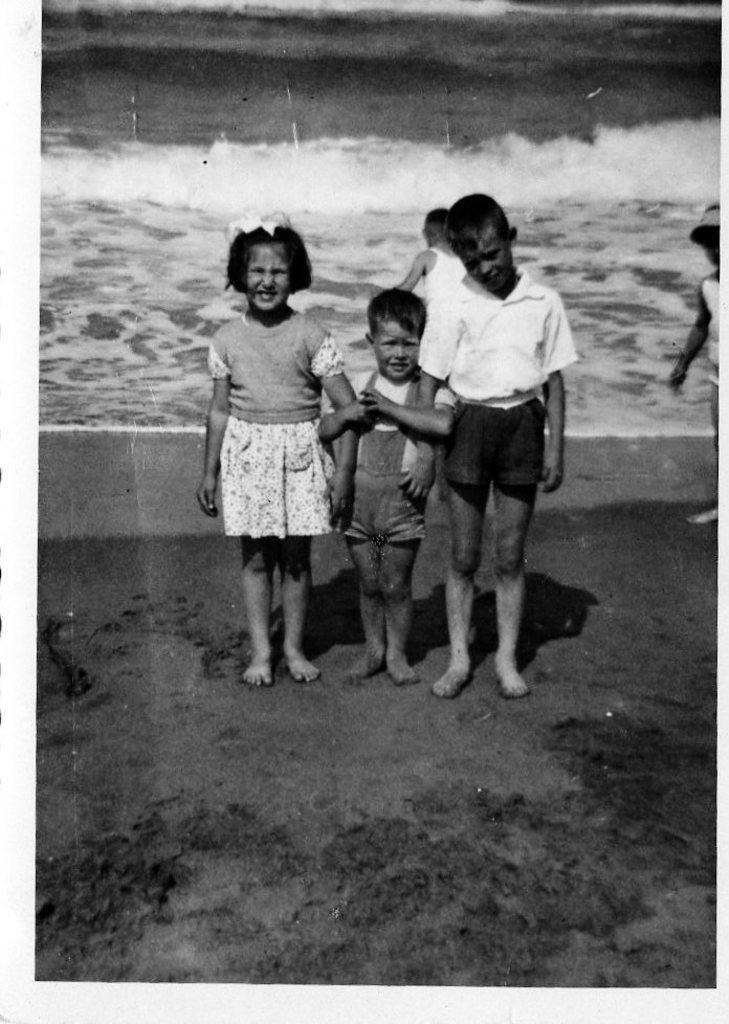How many children are in the image? There are three children in the image. What is the surface the children are standing on? The children are standing on the sand. What can be seen in the background of the image? There is an ocean visible in the background of the image. What type of bike is the child riding in the image? There is no bike present in the image; the children are standing on the sand. How many fingers does the child have in their mouth in the image? There is no child with fingers in their mouth in the image; the children are standing with their hands at their sides. 